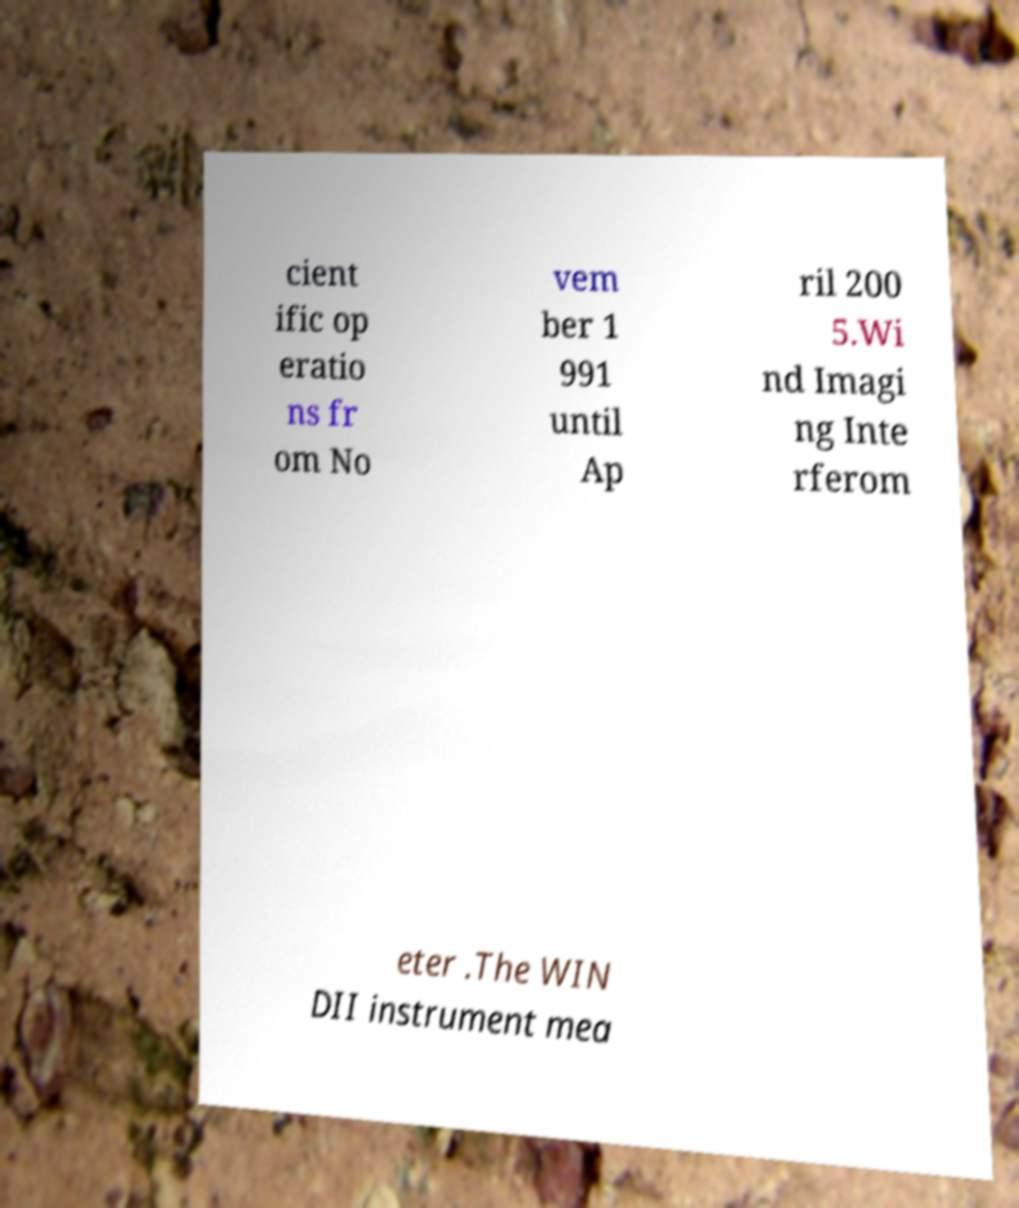Could you extract and type out the text from this image? cient ific op eratio ns fr om No vem ber 1 991 until Ap ril 200 5.Wi nd Imagi ng Inte rferom eter .The WIN DII instrument mea 